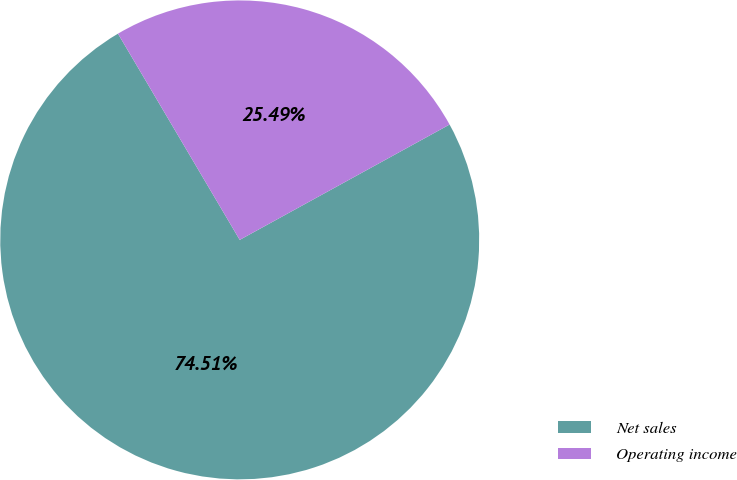<chart> <loc_0><loc_0><loc_500><loc_500><pie_chart><fcel>Net sales<fcel>Operating income<nl><fcel>74.51%<fcel>25.49%<nl></chart> 